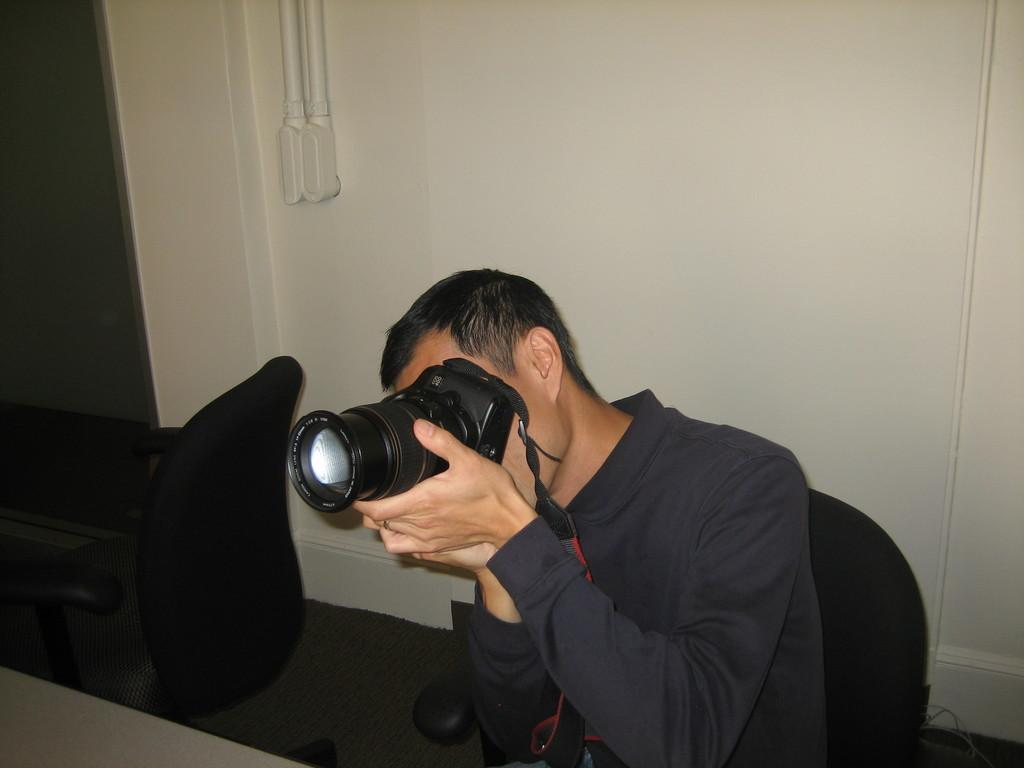Who is present in the image? There is a man in the image. What is the man holding in his hand? The man is holding a camera in his hand. What can be seen in the background of the image? There is a wall in the background of the image. What type of furniture is visible in the image? There is a table in the image. Can you see a cat sitting on the table in the image? There is no cat present in the image; only a man, a camera, a wall, and a table are visible. 